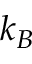Convert formula to latex. <formula><loc_0><loc_0><loc_500><loc_500>k _ { B }</formula> 